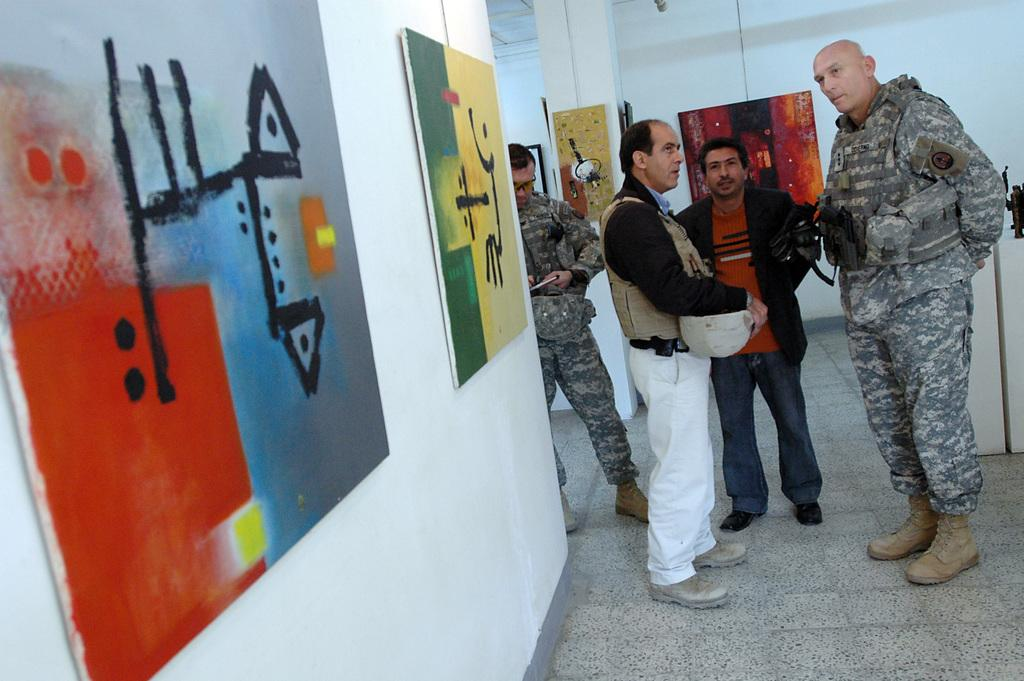What can be seen in the image? There are people standing in the image. Where are the people standing? The people are standing on the floor. What is present on the right side of the image? There are objects on the right side of the image. What can be seen on the wall in the image? There are photo frames on the wall. Can you see a friend of the people in the image sitting on a bed? There is no bed or friend present in the image. 